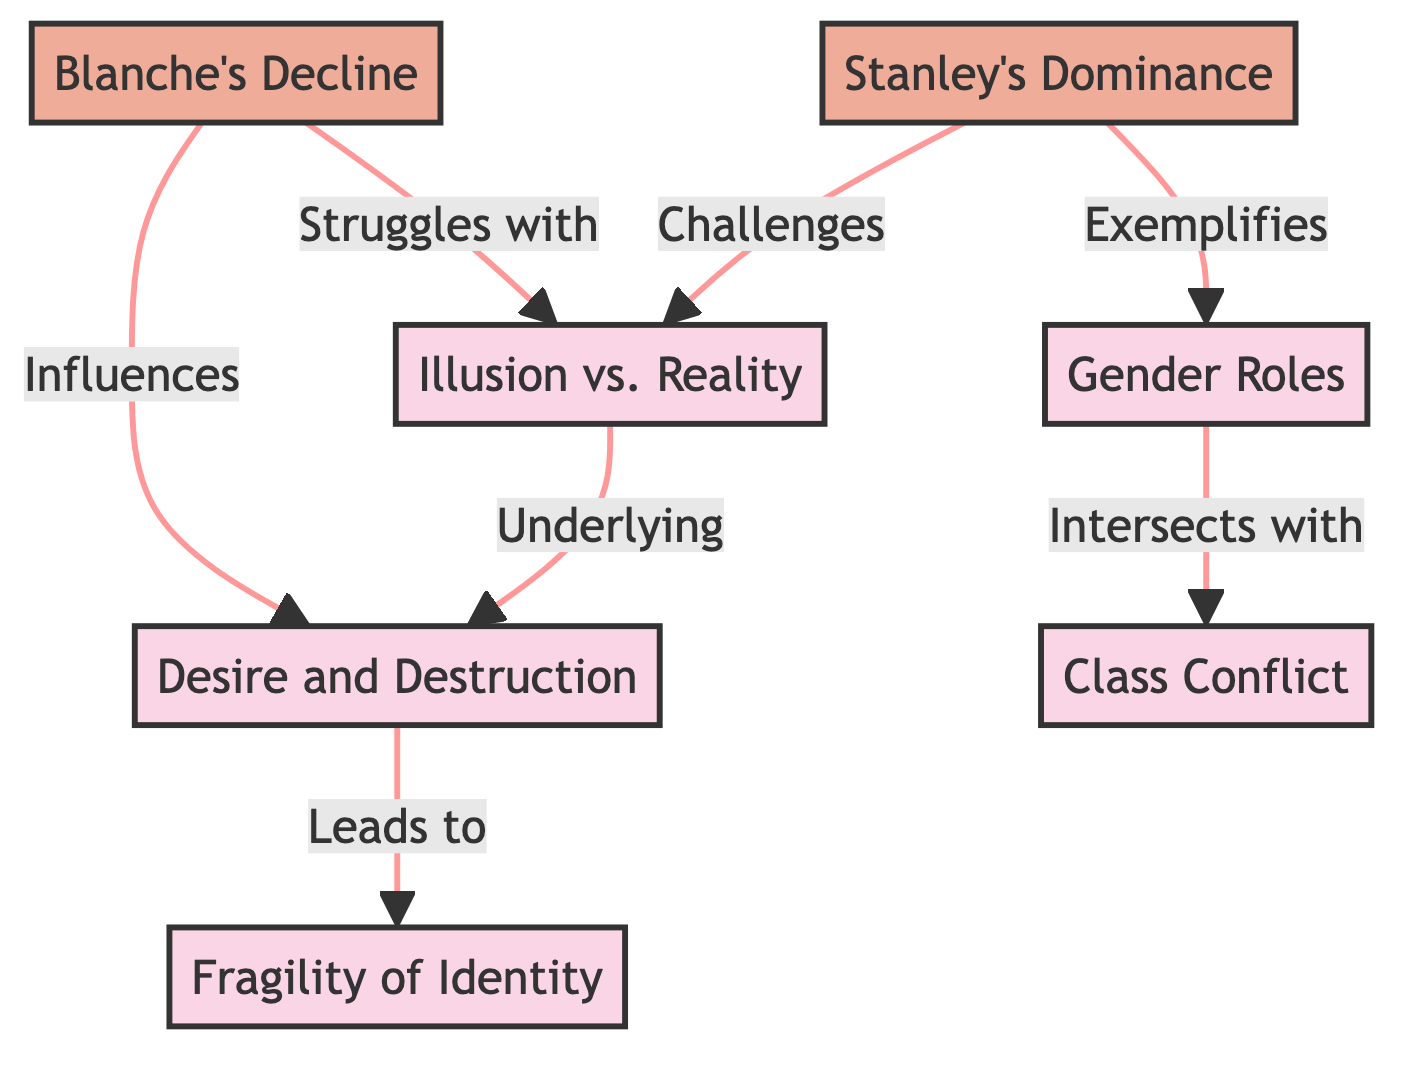What are the main themes represented in the diagram? The nodes labeled as "Illusion vs. Reality," "Desire and Destruction," "Fragility of Identity," "Gender Roles," and "Class Conflict" represent the main themes.
Answer: Illusion vs. Reality, Desire and Destruction, Fragility of Identity, Gender Roles, Class Conflict Which character struggles with "Illusion vs. Reality"? The edge pointing from "Blanche's Decline" to "Illusion vs. Reality" indicates that Blanche struggles with this theme.
Answer: Blanche How many nodes are in the diagram? The diagram has eight nodes in total, consisting of six thematic elements and two character representations.
Answer: 8 What influence does "Blanche's Decline" have according to the diagram? The edge indicates that "Blanche's Decline" influences the theme of "Desire and Destruction."
Answer: Influences Which theme intersects with "Gender Roles"? The edge pointing from "Gender Roles" to "Class Conflict" demonstrates that "Gender Roles" intersects with "Class Conflict."
Answer: Class Conflict Who exemplifies the theme of "Gender Roles"? The edge from "Stanley's Dominance" to "Gender Roles" signifies that Stanley exemplifies this theme.
Answer: Stanley What leads from "Desire and Destruction"? The edge shows that "Desire and Destruction" leads to "Fragility of Identity."
Answer: Leads to Which character challenges the theme of "Illusion vs. Reality"? The arrow from "Stanley's Dominance" to "Illusion vs. Reality" states that Stanley challenges this theme.
Answer: Stanley What is the relationship between "Illusion vs. Reality" and "Desire and Destruction"? The edge indicates that "Illusion vs. Reality" is an underlying theme of "Desire and Destruction."
Answer: Underlying 